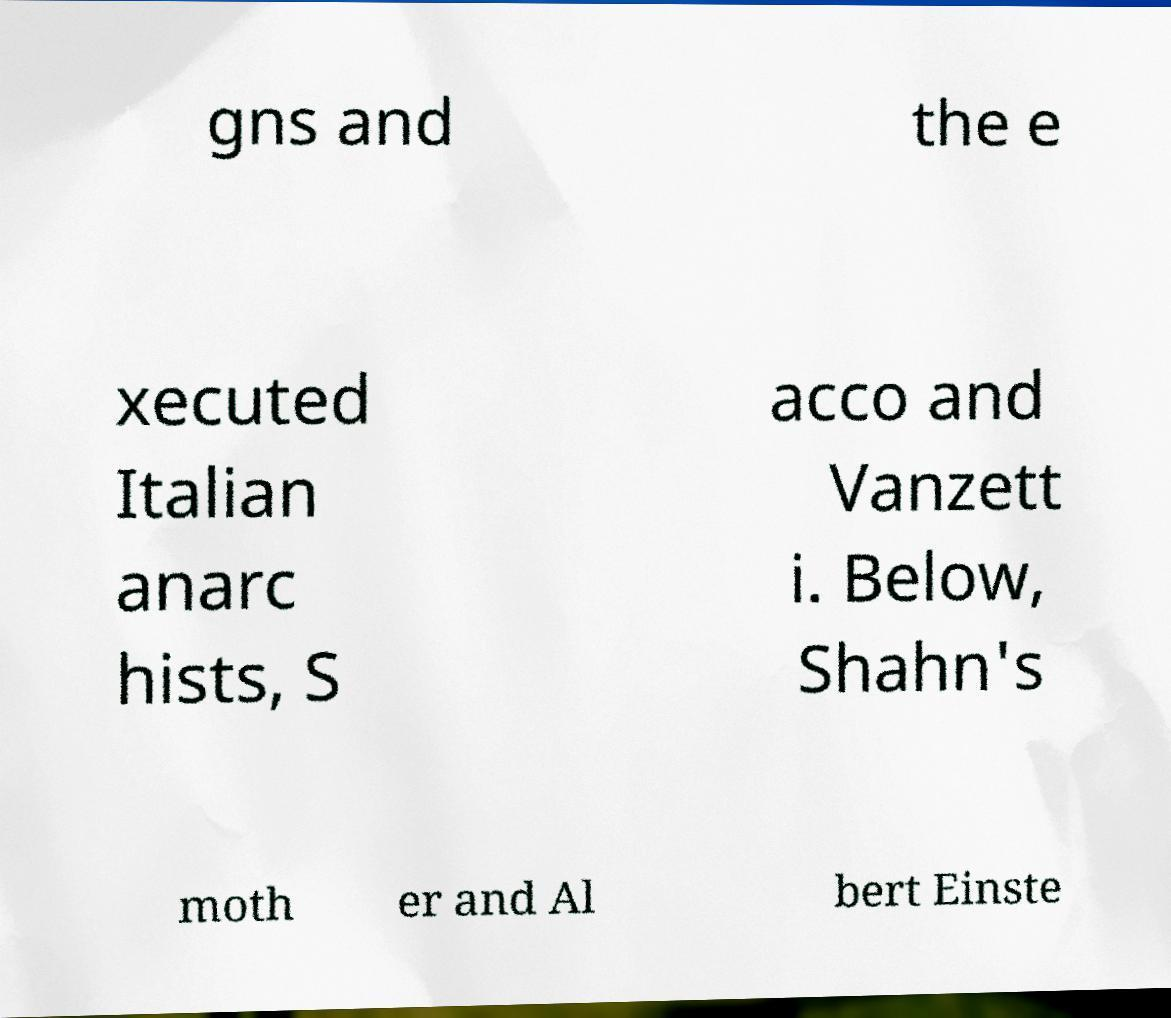Please identify and transcribe the text found in this image. gns and the e xecuted Italian anarc hists, S acco and Vanzett i. Below, Shahn's moth er and Al bert Einste 